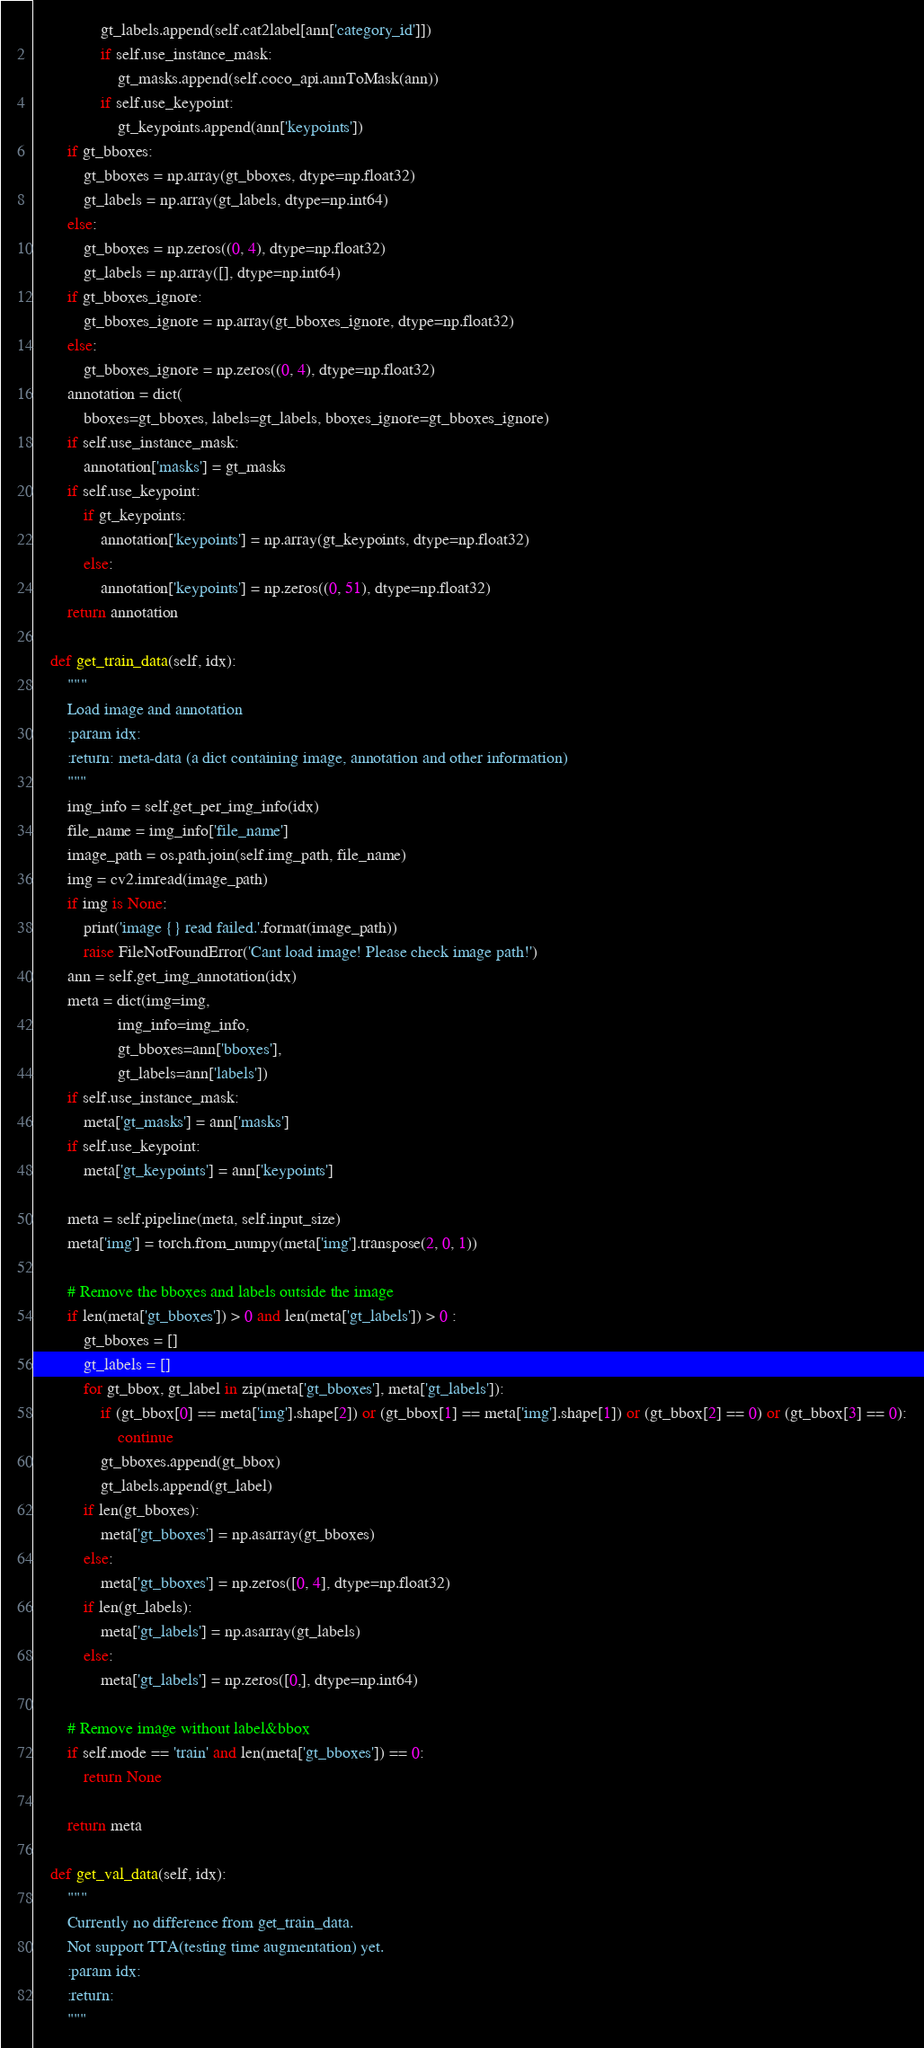<code> <loc_0><loc_0><loc_500><loc_500><_Python_>                gt_labels.append(self.cat2label[ann['category_id']])
                if self.use_instance_mask:
                    gt_masks.append(self.coco_api.annToMask(ann))
                if self.use_keypoint:
                    gt_keypoints.append(ann['keypoints'])
        if gt_bboxes:
            gt_bboxes = np.array(gt_bboxes, dtype=np.float32)
            gt_labels = np.array(gt_labels, dtype=np.int64)
        else:
            gt_bboxes = np.zeros((0, 4), dtype=np.float32)
            gt_labels = np.array([], dtype=np.int64)
        if gt_bboxes_ignore:
            gt_bboxes_ignore = np.array(gt_bboxes_ignore, dtype=np.float32)
        else:
            gt_bboxes_ignore = np.zeros((0, 4), dtype=np.float32)
        annotation = dict(
            bboxes=gt_bboxes, labels=gt_labels, bboxes_ignore=gt_bboxes_ignore)
        if self.use_instance_mask:
            annotation['masks'] = gt_masks
        if self.use_keypoint:
            if gt_keypoints:
                annotation['keypoints'] = np.array(gt_keypoints, dtype=np.float32)
            else:
                annotation['keypoints'] = np.zeros((0, 51), dtype=np.float32)
        return annotation

    def get_train_data(self, idx):
        """
        Load image and annotation
        :param idx:
        :return: meta-data (a dict containing image, annotation and other information)
        """
        img_info = self.get_per_img_info(idx)
        file_name = img_info['file_name']
        image_path = os.path.join(self.img_path, file_name)
        img = cv2.imread(image_path)
        if img is None:
            print('image {} read failed.'.format(image_path))
            raise FileNotFoundError('Cant load image! Please check image path!')
        ann = self.get_img_annotation(idx)
        meta = dict(img=img,
                    img_info=img_info,
                    gt_bboxes=ann['bboxes'],
                    gt_labels=ann['labels'])
        if self.use_instance_mask:
            meta['gt_masks'] = ann['masks']
        if self.use_keypoint:
            meta['gt_keypoints'] = ann['keypoints']

        meta = self.pipeline(meta, self.input_size)
        meta['img'] = torch.from_numpy(meta['img'].transpose(2, 0, 1))

        # Remove the bboxes and labels outside the image
        if len(meta['gt_bboxes']) > 0 and len(meta['gt_labels']) > 0 :
            gt_bboxes = []
            gt_labels = []
            for gt_bbox, gt_label in zip(meta['gt_bboxes'], meta['gt_labels']):
                if (gt_bbox[0] == meta['img'].shape[2]) or (gt_bbox[1] == meta['img'].shape[1]) or (gt_bbox[2] == 0) or (gt_bbox[3] == 0):
                    continue
                gt_bboxes.append(gt_bbox)
                gt_labels.append(gt_label)
            if len(gt_bboxes):
                meta['gt_bboxes'] = np.asarray(gt_bboxes)
            else:
                meta['gt_bboxes'] = np.zeros([0, 4], dtype=np.float32)
            if len(gt_labels):
                meta['gt_labels'] = np.asarray(gt_labels)
            else:
                meta['gt_labels'] = np.zeros([0,], dtype=np.int64)

        # Remove image without label&bbox
        if self.mode == 'train' and len(meta['gt_bboxes']) == 0:
            return None

        return meta

    def get_val_data(self, idx):
        """
        Currently no difference from get_train_data.
        Not support TTA(testing time augmentation) yet.
        :param idx:
        :return:
        """</code> 